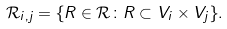<formula> <loc_0><loc_0><loc_500><loc_500>\mathcal { R } _ { i , j } = \{ R \in \mathcal { R } \colon R \subset V _ { i } \times V _ { j } \} .</formula> 